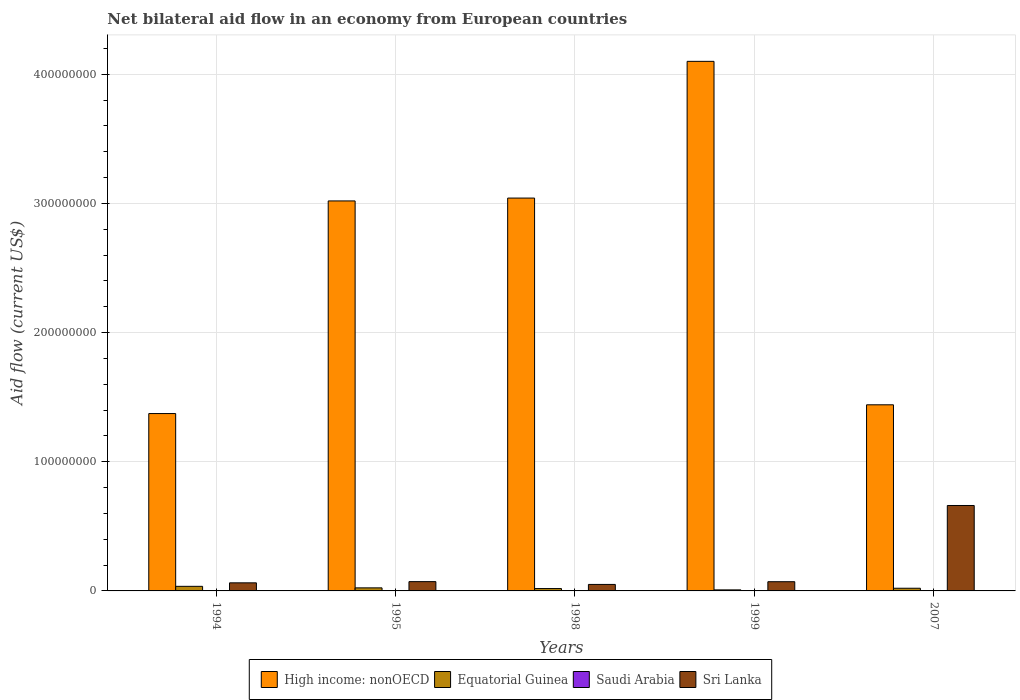How many different coloured bars are there?
Provide a short and direct response. 4. Are the number of bars per tick equal to the number of legend labels?
Give a very brief answer. Yes. How many bars are there on the 5th tick from the left?
Your answer should be very brief. 4. What is the net bilateral aid flow in High income: nonOECD in 1994?
Give a very brief answer. 1.37e+08. Across all years, what is the maximum net bilateral aid flow in High income: nonOECD?
Your response must be concise. 4.10e+08. What is the total net bilateral aid flow in High income: nonOECD in the graph?
Your answer should be very brief. 1.30e+09. What is the difference between the net bilateral aid flow in High income: nonOECD in 1994 and that in 1998?
Provide a succinct answer. -1.67e+08. What is the difference between the net bilateral aid flow in Equatorial Guinea in 1994 and the net bilateral aid flow in Sri Lanka in 1995?
Provide a succinct answer. -3.64e+06. What is the average net bilateral aid flow in Sri Lanka per year?
Keep it short and to the point. 1.83e+07. In the year 1998, what is the difference between the net bilateral aid flow in Sri Lanka and net bilateral aid flow in Equatorial Guinea?
Ensure brevity in your answer.  3.19e+06. In how many years, is the net bilateral aid flow in Equatorial Guinea greater than 80000000 US$?
Offer a terse response. 0. What is the ratio of the net bilateral aid flow in Sri Lanka in 1994 to that in 2007?
Keep it short and to the point. 0.09. Is the net bilateral aid flow in Sri Lanka in 1998 less than that in 2007?
Make the answer very short. Yes. Is the difference between the net bilateral aid flow in Sri Lanka in 1995 and 1998 greater than the difference between the net bilateral aid flow in Equatorial Guinea in 1995 and 1998?
Your response must be concise. Yes. What is the difference between the highest and the second highest net bilateral aid flow in Equatorial Guinea?
Provide a short and direct response. 1.18e+06. What is the difference between the highest and the lowest net bilateral aid flow in Saudi Arabia?
Offer a very short reply. 1.50e+05. In how many years, is the net bilateral aid flow in High income: nonOECD greater than the average net bilateral aid flow in High income: nonOECD taken over all years?
Your answer should be compact. 3. Is it the case that in every year, the sum of the net bilateral aid flow in Equatorial Guinea and net bilateral aid flow in High income: nonOECD is greater than the sum of net bilateral aid flow in Saudi Arabia and net bilateral aid flow in Sri Lanka?
Provide a short and direct response. Yes. What does the 2nd bar from the left in 1998 represents?
Offer a very short reply. Equatorial Guinea. What does the 1st bar from the right in 1998 represents?
Offer a terse response. Sri Lanka. How many bars are there?
Make the answer very short. 20. What is the difference between two consecutive major ticks on the Y-axis?
Provide a short and direct response. 1.00e+08. Are the values on the major ticks of Y-axis written in scientific E-notation?
Provide a succinct answer. No. Does the graph contain grids?
Give a very brief answer. Yes. How are the legend labels stacked?
Provide a succinct answer. Horizontal. What is the title of the graph?
Offer a very short reply. Net bilateral aid flow in an economy from European countries. Does "Myanmar" appear as one of the legend labels in the graph?
Your answer should be compact. No. What is the Aid flow (current US$) of High income: nonOECD in 1994?
Your answer should be very brief. 1.37e+08. What is the Aid flow (current US$) in Equatorial Guinea in 1994?
Offer a very short reply. 3.55e+06. What is the Aid flow (current US$) of Saudi Arabia in 1994?
Keep it short and to the point. 1.10e+05. What is the Aid flow (current US$) in Sri Lanka in 1994?
Keep it short and to the point. 6.26e+06. What is the Aid flow (current US$) of High income: nonOECD in 1995?
Provide a succinct answer. 3.02e+08. What is the Aid flow (current US$) in Equatorial Guinea in 1995?
Your answer should be compact. 2.37e+06. What is the Aid flow (current US$) in Sri Lanka in 1995?
Ensure brevity in your answer.  7.19e+06. What is the Aid flow (current US$) of High income: nonOECD in 1998?
Make the answer very short. 3.04e+08. What is the Aid flow (current US$) in Equatorial Guinea in 1998?
Your answer should be compact. 1.83e+06. What is the Aid flow (current US$) of Saudi Arabia in 1998?
Provide a succinct answer. 10000. What is the Aid flow (current US$) in Sri Lanka in 1998?
Provide a short and direct response. 5.02e+06. What is the Aid flow (current US$) in High income: nonOECD in 1999?
Offer a terse response. 4.10e+08. What is the Aid flow (current US$) of Equatorial Guinea in 1999?
Offer a very short reply. 8.00e+05. What is the Aid flow (current US$) of Sri Lanka in 1999?
Your answer should be very brief. 7.13e+06. What is the Aid flow (current US$) of High income: nonOECD in 2007?
Provide a short and direct response. 1.44e+08. What is the Aid flow (current US$) of Equatorial Guinea in 2007?
Your answer should be very brief. 2.07e+06. What is the Aid flow (current US$) of Saudi Arabia in 2007?
Provide a succinct answer. 10000. What is the Aid flow (current US$) in Sri Lanka in 2007?
Provide a succinct answer. 6.61e+07. Across all years, what is the maximum Aid flow (current US$) of High income: nonOECD?
Your response must be concise. 4.10e+08. Across all years, what is the maximum Aid flow (current US$) of Equatorial Guinea?
Your answer should be compact. 3.55e+06. Across all years, what is the maximum Aid flow (current US$) of Sri Lanka?
Offer a very short reply. 6.61e+07. Across all years, what is the minimum Aid flow (current US$) of High income: nonOECD?
Ensure brevity in your answer.  1.37e+08. Across all years, what is the minimum Aid flow (current US$) in Equatorial Guinea?
Your answer should be very brief. 8.00e+05. Across all years, what is the minimum Aid flow (current US$) in Saudi Arabia?
Make the answer very short. 10000. Across all years, what is the minimum Aid flow (current US$) in Sri Lanka?
Make the answer very short. 5.02e+06. What is the total Aid flow (current US$) in High income: nonOECD in the graph?
Provide a succinct answer. 1.30e+09. What is the total Aid flow (current US$) in Equatorial Guinea in the graph?
Keep it short and to the point. 1.06e+07. What is the total Aid flow (current US$) in Saudi Arabia in the graph?
Your answer should be very brief. 3.70e+05. What is the total Aid flow (current US$) of Sri Lanka in the graph?
Your answer should be compact. 9.17e+07. What is the difference between the Aid flow (current US$) of High income: nonOECD in 1994 and that in 1995?
Offer a terse response. -1.65e+08. What is the difference between the Aid flow (current US$) in Equatorial Guinea in 1994 and that in 1995?
Offer a very short reply. 1.18e+06. What is the difference between the Aid flow (current US$) of Sri Lanka in 1994 and that in 1995?
Your answer should be very brief. -9.30e+05. What is the difference between the Aid flow (current US$) in High income: nonOECD in 1994 and that in 1998?
Ensure brevity in your answer.  -1.67e+08. What is the difference between the Aid flow (current US$) in Equatorial Guinea in 1994 and that in 1998?
Offer a very short reply. 1.72e+06. What is the difference between the Aid flow (current US$) of Sri Lanka in 1994 and that in 1998?
Offer a terse response. 1.24e+06. What is the difference between the Aid flow (current US$) in High income: nonOECD in 1994 and that in 1999?
Your answer should be compact. -2.73e+08. What is the difference between the Aid flow (current US$) in Equatorial Guinea in 1994 and that in 1999?
Ensure brevity in your answer.  2.75e+06. What is the difference between the Aid flow (current US$) in Saudi Arabia in 1994 and that in 1999?
Offer a terse response. 3.00e+04. What is the difference between the Aid flow (current US$) of Sri Lanka in 1994 and that in 1999?
Give a very brief answer. -8.70e+05. What is the difference between the Aid flow (current US$) in High income: nonOECD in 1994 and that in 2007?
Ensure brevity in your answer.  -6.77e+06. What is the difference between the Aid flow (current US$) of Equatorial Guinea in 1994 and that in 2007?
Keep it short and to the point. 1.48e+06. What is the difference between the Aid flow (current US$) in Saudi Arabia in 1994 and that in 2007?
Provide a short and direct response. 1.00e+05. What is the difference between the Aid flow (current US$) in Sri Lanka in 1994 and that in 2007?
Offer a terse response. -5.99e+07. What is the difference between the Aid flow (current US$) in High income: nonOECD in 1995 and that in 1998?
Provide a succinct answer. -2.21e+06. What is the difference between the Aid flow (current US$) of Equatorial Guinea in 1995 and that in 1998?
Your answer should be compact. 5.40e+05. What is the difference between the Aid flow (current US$) in Saudi Arabia in 1995 and that in 1998?
Your answer should be compact. 1.50e+05. What is the difference between the Aid flow (current US$) in Sri Lanka in 1995 and that in 1998?
Provide a succinct answer. 2.17e+06. What is the difference between the Aid flow (current US$) of High income: nonOECD in 1995 and that in 1999?
Your answer should be compact. -1.08e+08. What is the difference between the Aid flow (current US$) of Equatorial Guinea in 1995 and that in 1999?
Give a very brief answer. 1.57e+06. What is the difference between the Aid flow (current US$) in Sri Lanka in 1995 and that in 1999?
Offer a terse response. 6.00e+04. What is the difference between the Aid flow (current US$) in High income: nonOECD in 1995 and that in 2007?
Give a very brief answer. 1.58e+08. What is the difference between the Aid flow (current US$) in Equatorial Guinea in 1995 and that in 2007?
Provide a short and direct response. 3.00e+05. What is the difference between the Aid flow (current US$) of Sri Lanka in 1995 and that in 2007?
Your answer should be compact. -5.90e+07. What is the difference between the Aid flow (current US$) in High income: nonOECD in 1998 and that in 1999?
Keep it short and to the point. -1.06e+08. What is the difference between the Aid flow (current US$) in Equatorial Guinea in 1998 and that in 1999?
Offer a very short reply. 1.03e+06. What is the difference between the Aid flow (current US$) of Sri Lanka in 1998 and that in 1999?
Your response must be concise. -2.11e+06. What is the difference between the Aid flow (current US$) in High income: nonOECD in 1998 and that in 2007?
Provide a short and direct response. 1.60e+08. What is the difference between the Aid flow (current US$) in Equatorial Guinea in 1998 and that in 2007?
Your answer should be compact. -2.40e+05. What is the difference between the Aid flow (current US$) in Sri Lanka in 1998 and that in 2007?
Your answer should be very brief. -6.11e+07. What is the difference between the Aid flow (current US$) of High income: nonOECD in 1999 and that in 2007?
Offer a terse response. 2.66e+08. What is the difference between the Aid flow (current US$) in Equatorial Guinea in 1999 and that in 2007?
Make the answer very short. -1.27e+06. What is the difference between the Aid flow (current US$) in Sri Lanka in 1999 and that in 2007?
Your answer should be compact. -5.90e+07. What is the difference between the Aid flow (current US$) in High income: nonOECD in 1994 and the Aid flow (current US$) in Equatorial Guinea in 1995?
Your answer should be very brief. 1.35e+08. What is the difference between the Aid flow (current US$) in High income: nonOECD in 1994 and the Aid flow (current US$) in Saudi Arabia in 1995?
Make the answer very short. 1.37e+08. What is the difference between the Aid flow (current US$) in High income: nonOECD in 1994 and the Aid flow (current US$) in Sri Lanka in 1995?
Provide a short and direct response. 1.30e+08. What is the difference between the Aid flow (current US$) in Equatorial Guinea in 1994 and the Aid flow (current US$) in Saudi Arabia in 1995?
Provide a succinct answer. 3.39e+06. What is the difference between the Aid flow (current US$) of Equatorial Guinea in 1994 and the Aid flow (current US$) of Sri Lanka in 1995?
Make the answer very short. -3.64e+06. What is the difference between the Aid flow (current US$) of Saudi Arabia in 1994 and the Aid flow (current US$) of Sri Lanka in 1995?
Ensure brevity in your answer.  -7.08e+06. What is the difference between the Aid flow (current US$) of High income: nonOECD in 1994 and the Aid flow (current US$) of Equatorial Guinea in 1998?
Ensure brevity in your answer.  1.35e+08. What is the difference between the Aid flow (current US$) of High income: nonOECD in 1994 and the Aid flow (current US$) of Saudi Arabia in 1998?
Your answer should be very brief. 1.37e+08. What is the difference between the Aid flow (current US$) of High income: nonOECD in 1994 and the Aid flow (current US$) of Sri Lanka in 1998?
Give a very brief answer. 1.32e+08. What is the difference between the Aid flow (current US$) in Equatorial Guinea in 1994 and the Aid flow (current US$) in Saudi Arabia in 1998?
Ensure brevity in your answer.  3.54e+06. What is the difference between the Aid flow (current US$) of Equatorial Guinea in 1994 and the Aid flow (current US$) of Sri Lanka in 1998?
Make the answer very short. -1.47e+06. What is the difference between the Aid flow (current US$) of Saudi Arabia in 1994 and the Aid flow (current US$) of Sri Lanka in 1998?
Make the answer very short. -4.91e+06. What is the difference between the Aid flow (current US$) of High income: nonOECD in 1994 and the Aid flow (current US$) of Equatorial Guinea in 1999?
Give a very brief answer. 1.37e+08. What is the difference between the Aid flow (current US$) in High income: nonOECD in 1994 and the Aid flow (current US$) in Saudi Arabia in 1999?
Make the answer very short. 1.37e+08. What is the difference between the Aid flow (current US$) in High income: nonOECD in 1994 and the Aid flow (current US$) in Sri Lanka in 1999?
Give a very brief answer. 1.30e+08. What is the difference between the Aid flow (current US$) of Equatorial Guinea in 1994 and the Aid flow (current US$) of Saudi Arabia in 1999?
Ensure brevity in your answer.  3.47e+06. What is the difference between the Aid flow (current US$) of Equatorial Guinea in 1994 and the Aid flow (current US$) of Sri Lanka in 1999?
Keep it short and to the point. -3.58e+06. What is the difference between the Aid flow (current US$) of Saudi Arabia in 1994 and the Aid flow (current US$) of Sri Lanka in 1999?
Provide a succinct answer. -7.02e+06. What is the difference between the Aid flow (current US$) in High income: nonOECD in 1994 and the Aid flow (current US$) in Equatorial Guinea in 2007?
Offer a very short reply. 1.35e+08. What is the difference between the Aid flow (current US$) in High income: nonOECD in 1994 and the Aid flow (current US$) in Saudi Arabia in 2007?
Keep it short and to the point. 1.37e+08. What is the difference between the Aid flow (current US$) of High income: nonOECD in 1994 and the Aid flow (current US$) of Sri Lanka in 2007?
Provide a succinct answer. 7.12e+07. What is the difference between the Aid flow (current US$) of Equatorial Guinea in 1994 and the Aid flow (current US$) of Saudi Arabia in 2007?
Ensure brevity in your answer.  3.54e+06. What is the difference between the Aid flow (current US$) of Equatorial Guinea in 1994 and the Aid flow (current US$) of Sri Lanka in 2007?
Ensure brevity in your answer.  -6.26e+07. What is the difference between the Aid flow (current US$) in Saudi Arabia in 1994 and the Aid flow (current US$) in Sri Lanka in 2007?
Keep it short and to the point. -6.60e+07. What is the difference between the Aid flow (current US$) of High income: nonOECD in 1995 and the Aid flow (current US$) of Equatorial Guinea in 1998?
Provide a succinct answer. 3.00e+08. What is the difference between the Aid flow (current US$) in High income: nonOECD in 1995 and the Aid flow (current US$) in Saudi Arabia in 1998?
Provide a succinct answer. 3.02e+08. What is the difference between the Aid flow (current US$) of High income: nonOECD in 1995 and the Aid flow (current US$) of Sri Lanka in 1998?
Make the answer very short. 2.97e+08. What is the difference between the Aid flow (current US$) in Equatorial Guinea in 1995 and the Aid flow (current US$) in Saudi Arabia in 1998?
Provide a short and direct response. 2.36e+06. What is the difference between the Aid flow (current US$) of Equatorial Guinea in 1995 and the Aid flow (current US$) of Sri Lanka in 1998?
Offer a very short reply. -2.65e+06. What is the difference between the Aid flow (current US$) of Saudi Arabia in 1995 and the Aid flow (current US$) of Sri Lanka in 1998?
Offer a very short reply. -4.86e+06. What is the difference between the Aid flow (current US$) in High income: nonOECD in 1995 and the Aid flow (current US$) in Equatorial Guinea in 1999?
Provide a succinct answer. 3.01e+08. What is the difference between the Aid flow (current US$) in High income: nonOECD in 1995 and the Aid flow (current US$) in Saudi Arabia in 1999?
Your answer should be very brief. 3.02e+08. What is the difference between the Aid flow (current US$) of High income: nonOECD in 1995 and the Aid flow (current US$) of Sri Lanka in 1999?
Your response must be concise. 2.95e+08. What is the difference between the Aid flow (current US$) of Equatorial Guinea in 1995 and the Aid flow (current US$) of Saudi Arabia in 1999?
Keep it short and to the point. 2.29e+06. What is the difference between the Aid flow (current US$) of Equatorial Guinea in 1995 and the Aid flow (current US$) of Sri Lanka in 1999?
Your response must be concise. -4.76e+06. What is the difference between the Aid flow (current US$) in Saudi Arabia in 1995 and the Aid flow (current US$) in Sri Lanka in 1999?
Your answer should be compact. -6.97e+06. What is the difference between the Aid flow (current US$) in High income: nonOECD in 1995 and the Aid flow (current US$) in Equatorial Guinea in 2007?
Give a very brief answer. 3.00e+08. What is the difference between the Aid flow (current US$) of High income: nonOECD in 1995 and the Aid flow (current US$) of Saudi Arabia in 2007?
Ensure brevity in your answer.  3.02e+08. What is the difference between the Aid flow (current US$) in High income: nonOECD in 1995 and the Aid flow (current US$) in Sri Lanka in 2007?
Your response must be concise. 2.36e+08. What is the difference between the Aid flow (current US$) of Equatorial Guinea in 1995 and the Aid flow (current US$) of Saudi Arabia in 2007?
Your response must be concise. 2.36e+06. What is the difference between the Aid flow (current US$) in Equatorial Guinea in 1995 and the Aid flow (current US$) in Sri Lanka in 2007?
Your answer should be compact. -6.38e+07. What is the difference between the Aid flow (current US$) in Saudi Arabia in 1995 and the Aid flow (current US$) in Sri Lanka in 2007?
Offer a very short reply. -6.60e+07. What is the difference between the Aid flow (current US$) of High income: nonOECD in 1998 and the Aid flow (current US$) of Equatorial Guinea in 1999?
Your response must be concise. 3.03e+08. What is the difference between the Aid flow (current US$) of High income: nonOECD in 1998 and the Aid flow (current US$) of Saudi Arabia in 1999?
Offer a very short reply. 3.04e+08. What is the difference between the Aid flow (current US$) in High income: nonOECD in 1998 and the Aid flow (current US$) in Sri Lanka in 1999?
Provide a succinct answer. 2.97e+08. What is the difference between the Aid flow (current US$) in Equatorial Guinea in 1998 and the Aid flow (current US$) in Saudi Arabia in 1999?
Make the answer very short. 1.75e+06. What is the difference between the Aid flow (current US$) of Equatorial Guinea in 1998 and the Aid flow (current US$) of Sri Lanka in 1999?
Your response must be concise. -5.30e+06. What is the difference between the Aid flow (current US$) in Saudi Arabia in 1998 and the Aid flow (current US$) in Sri Lanka in 1999?
Your answer should be very brief. -7.12e+06. What is the difference between the Aid flow (current US$) of High income: nonOECD in 1998 and the Aid flow (current US$) of Equatorial Guinea in 2007?
Offer a very short reply. 3.02e+08. What is the difference between the Aid flow (current US$) in High income: nonOECD in 1998 and the Aid flow (current US$) in Saudi Arabia in 2007?
Give a very brief answer. 3.04e+08. What is the difference between the Aid flow (current US$) of High income: nonOECD in 1998 and the Aid flow (current US$) of Sri Lanka in 2007?
Keep it short and to the point. 2.38e+08. What is the difference between the Aid flow (current US$) of Equatorial Guinea in 1998 and the Aid flow (current US$) of Saudi Arabia in 2007?
Provide a short and direct response. 1.82e+06. What is the difference between the Aid flow (current US$) in Equatorial Guinea in 1998 and the Aid flow (current US$) in Sri Lanka in 2007?
Offer a very short reply. -6.43e+07. What is the difference between the Aid flow (current US$) of Saudi Arabia in 1998 and the Aid flow (current US$) of Sri Lanka in 2007?
Make the answer very short. -6.61e+07. What is the difference between the Aid flow (current US$) in High income: nonOECD in 1999 and the Aid flow (current US$) in Equatorial Guinea in 2007?
Your response must be concise. 4.08e+08. What is the difference between the Aid flow (current US$) in High income: nonOECD in 1999 and the Aid flow (current US$) in Saudi Arabia in 2007?
Keep it short and to the point. 4.10e+08. What is the difference between the Aid flow (current US$) of High income: nonOECD in 1999 and the Aid flow (current US$) of Sri Lanka in 2007?
Make the answer very short. 3.44e+08. What is the difference between the Aid flow (current US$) in Equatorial Guinea in 1999 and the Aid flow (current US$) in Saudi Arabia in 2007?
Keep it short and to the point. 7.90e+05. What is the difference between the Aid flow (current US$) of Equatorial Guinea in 1999 and the Aid flow (current US$) of Sri Lanka in 2007?
Your response must be concise. -6.53e+07. What is the difference between the Aid flow (current US$) of Saudi Arabia in 1999 and the Aid flow (current US$) of Sri Lanka in 2007?
Offer a terse response. -6.61e+07. What is the average Aid flow (current US$) of High income: nonOECD per year?
Ensure brevity in your answer.  2.60e+08. What is the average Aid flow (current US$) in Equatorial Guinea per year?
Offer a terse response. 2.12e+06. What is the average Aid flow (current US$) of Saudi Arabia per year?
Provide a short and direct response. 7.40e+04. What is the average Aid flow (current US$) in Sri Lanka per year?
Provide a succinct answer. 1.83e+07. In the year 1994, what is the difference between the Aid flow (current US$) of High income: nonOECD and Aid flow (current US$) of Equatorial Guinea?
Offer a very short reply. 1.34e+08. In the year 1994, what is the difference between the Aid flow (current US$) in High income: nonOECD and Aid flow (current US$) in Saudi Arabia?
Keep it short and to the point. 1.37e+08. In the year 1994, what is the difference between the Aid flow (current US$) of High income: nonOECD and Aid flow (current US$) of Sri Lanka?
Your answer should be compact. 1.31e+08. In the year 1994, what is the difference between the Aid flow (current US$) in Equatorial Guinea and Aid flow (current US$) in Saudi Arabia?
Offer a very short reply. 3.44e+06. In the year 1994, what is the difference between the Aid flow (current US$) in Equatorial Guinea and Aid flow (current US$) in Sri Lanka?
Provide a short and direct response. -2.71e+06. In the year 1994, what is the difference between the Aid flow (current US$) of Saudi Arabia and Aid flow (current US$) of Sri Lanka?
Your response must be concise. -6.15e+06. In the year 1995, what is the difference between the Aid flow (current US$) of High income: nonOECD and Aid flow (current US$) of Equatorial Guinea?
Your response must be concise. 3.00e+08. In the year 1995, what is the difference between the Aid flow (current US$) of High income: nonOECD and Aid flow (current US$) of Saudi Arabia?
Provide a short and direct response. 3.02e+08. In the year 1995, what is the difference between the Aid flow (current US$) of High income: nonOECD and Aid flow (current US$) of Sri Lanka?
Keep it short and to the point. 2.95e+08. In the year 1995, what is the difference between the Aid flow (current US$) in Equatorial Guinea and Aid flow (current US$) in Saudi Arabia?
Provide a succinct answer. 2.21e+06. In the year 1995, what is the difference between the Aid flow (current US$) in Equatorial Guinea and Aid flow (current US$) in Sri Lanka?
Keep it short and to the point. -4.82e+06. In the year 1995, what is the difference between the Aid flow (current US$) in Saudi Arabia and Aid flow (current US$) in Sri Lanka?
Provide a short and direct response. -7.03e+06. In the year 1998, what is the difference between the Aid flow (current US$) of High income: nonOECD and Aid flow (current US$) of Equatorial Guinea?
Give a very brief answer. 3.02e+08. In the year 1998, what is the difference between the Aid flow (current US$) of High income: nonOECD and Aid flow (current US$) of Saudi Arabia?
Ensure brevity in your answer.  3.04e+08. In the year 1998, what is the difference between the Aid flow (current US$) in High income: nonOECD and Aid flow (current US$) in Sri Lanka?
Ensure brevity in your answer.  2.99e+08. In the year 1998, what is the difference between the Aid flow (current US$) in Equatorial Guinea and Aid flow (current US$) in Saudi Arabia?
Ensure brevity in your answer.  1.82e+06. In the year 1998, what is the difference between the Aid flow (current US$) of Equatorial Guinea and Aid flow (current US$) of Sri Lanka?
Your answer should be very brief. -3.19e+06. In the year 1998, what is the difference between the Aid flow (current US$) in Saudi Arabia and Aid flow (current US$) in Sri Lanka?
Offer a very short reply. -5.01e+06. In the year 1999, what is the difference between the Aid flow (current US$) in High income: nonOECD and Aid flow (current US$) in Equatorial Guinea?
Your response must be concise. 4.09e+08. In the year 1999, what is the difference between the Aid flow (current US$) of High income: nonOECD and Aid flow (current US$) of Saudi Arabia?
Your response must be concise. 4.10e+08. In the year 1999, what is the difference between the Aid flow (current US$) of High income: nonOECD and Aid flow (current US$) of Sri Lanka?
Your answer should be compact. 4.03e+08. In the year 1999, what is the difference between the Aid flow (current US$) of Equatorial Guinea and Aid flow (current US$) of Saudi Arabia?
Provide a succinct answer. 7.20e+05. In the year 1999, what is the difference between the Aid flow (current US$) of Equatorial Guinea and Aid flow (current US$) of Sri Lanka?
Give a very brief answer. -6.33e+06. In the year 1999, what is the difference between the Aid flow (current US$) of Saudi Arabia and Aid flow (current US$) of Sri Lanka?
Provide a short and direct response. -7.05e+06. In the year 2007, what is the difference between the Aid flow (current US$) in High income: nonOECD and Aid flow (current US$) in Equatorial Guinea?
Provide a succinct answer. 1.42e+08. In the year 2007, what is the difference between the Aid flow (current US$) in High income: nonOECD and Aid flow (current US$) in Saudi Arabia?
Ensure brevity in your answer.  1.44e+08. In the year 2007, what is the difference between the Aid flow (current US$) of High income: nonOECD and Aid flow (current US$) of Sri Lanka?
Provide a short and direct response. 7.80e+07. In the year 2007, what is the difference between the Aid flow (current US$) of Equatorial Guinea and Aid flow (current US$) of Saudi Arabia?
Your answer should be very brief. 2.06e+06. In the year 2007, what is the difference between the Aid flow (current US$) in Equatorial Guinea and Aid flow (current US$) in Sri Lanka?
Your answer should be compact. -6.41e+07. In the year 2007, what is the difference between the Aid flow (current US$) of Saudi Arabia and Aid flow (current US$) of Sri Lanka?
Your answer should be compact. -6.61e+07. What is the ratio of the Aid flow (current US$) in High income: nonOECD in 1994 to that in 1995?
Ensure brevity in your answer.  0.45. What is the ratio of the Aid flow (current US$) of Equatorial Guinea in 1994 to that in 1995?
Keep it short and to the point. 1.5. What is the ratio of the Aid flow (current US$) of Saudi Arabia in 1994 to that in 1995?
Keep it short and to the point. 0.69. What is the ratio of the Aid flow (current US$) in Sri Lanka in 1994 to that in 1995?
Your answer should be compact. 0.87. What is the ratio of the Aid flow (current US$) of High income: nonOECD in 1994 to that in 1998?
Keep it short and to the point. 0.45. What is the ratio of the Aid flow (current US$) in Equatorial Guinea in 1994 to that in 1998?
Give a very brief answer. 1.94. What is the ratio of the Aid flow (current US$) of Saudi Arabia in 1994 to that in 1998?
Your answer should be very brief. 11. What is the ratio of the Aid flow (current US$) of Sri Lanka in 1994 to that in 1998?
Offer a very short reply. 1.25. What is the ratio of the Aid flow (current US$) of High income: nonOECD in 1994 to that in 1999?
Make the answer very short. 0.33. What is the ratio of the Aid flow (current US$) of Equatorial Guinea in 1994 to that in 1999?
Make the answer very short. 4.44. What is the ratio of the Aid flow (current US$) of Saudi Arabia in 1994 to that in 1999?
Ensure brevity in your answer.  1.38. What is the ratio of the Aid flow (current US$) of Sri Lanka in 1994 to that in 1999?
Ensure brevity in your answer.  0.88. What is the ratio of the Aid flow (current US$) of High income: nonOECD in 1994 to that in 2007?
Provide a short and direct response. 0.95. What is the ratio of the Aid flow (current US$) of Equatorial Guinea in 1994 to that in 2007?
Provide a short and direct response. 1.72. What is the ratio of the Aid flow (current US$) of Saudi Arabia in 1994 to that in 2007?
Provide a short and direct response. 11. What is the ratio of the Aid flow (current US$) in Sri Lanka in 1994 to that in 2007?
Make the answer very short. 0.09. What is the ratio of the Aid flow (current US$) of High income: nonOECD in 1995 to that in 1998?
Keep it short and to the point. 0.99. What is the ratio of the Aid flow (current US$) of Equatorial Guinea in 1995 to that in 1998?
Your response must be concise. 1.3. What is the ratio of the Aid flow (current US$) of Sri Lanka in 1995 to that in 1998?
Provide a short and direct response. 1.43. What is the ratio of the Aid flow (current US$) of High income: nonOECD in 1995 to that in 1999?
Your response must be concise. 0.74. What is the ratio of the Aid flow (current US$) of Equatorial Guinea in 1995 to that in 1999?
Keep it short and to the point. 2.96. What is the ratio of the Aid flow (current US$) of Sri Lanka in 1995 to that in 1999?
Offer a very short reply. 1.01. What is the ratio of the Aid flow (current US$) of High income: nonOECD in 1995 to that in 2007?
Provide a succinct answer. 2.1. What is the ratio of the Aid flow (current US$) in Equatorial Guinea in 1995 to that in 2007?
Your answer should be very brief. 1.14. What is the ratio of the Aid flow (current US$) of Sri Lanka in 1995 to that in 2007?
Your answer should be compact. 0.11. What is the ratio of the Aid flow (current US$) in High income: nonOECD in 1998 to that in 1999?
Give a very brief answer. 0.74. What is the ratio of the Aid flow (current US$) of Equatorial Guinea in 1998 to that in 1999?
Ensure brevity in your answer.  2.29. What is the ratio of the Aid flow (current US$) in Saudi Arabia in 1998 to that in 1999?
Give a very brief answer. 0.12. What is the ratio of the Aid flow (current US$) of Sri Lanka in 1998 to that in 1999?
Offer a terse response. 0.7. What is the ratio of the Aid flow (current US$) of High income: nonOECD in 1998 to that in 2007?
Make the answer very short. 2.11. What is the ratio of the Aid flow (current US$) of Equatorial Guinea in 1998 to that in 2007?
Your answer should be very brief. 0.88. What is the ratio of the Aid flow (current US$) of Saudi Arabia in 1998 to that in 2007?
Provide a succinct answer. 1. What is the ratio of the Aid flow (current US$) of Sri Lanka in 1998 to that in 2007?
Give a very brief answer. 0.08. What is the ratio of the Aid flow (current US$) in High income: nonOECD in 1999 to that in 2007?
Your response must be concise. 2.85. What is the ratio of the Aid flow (current US$) in Equatorial Guinea in 1999 to that in 2007?
Ensure brevity in your answer.  0.39. What is the ratio of the Aid flow (current US$) of Sri Lanka in 1999 to that in 2007?
Your answer should be compact. 0.11. What is the difference between the highest and the second highest Aid flow (current US$) in High income: nonOECD?
Your response must be concise. 1.06e+08. What is the difference between the highest and the second highest Aid flow (current US$) in Equatorial Guinea?
Provide a succinct answer. 1.18e+06. What is the difference between the highest and the second highest Aid flow (current US$) in Saudi Arabia?
Your answer should be very brief. 5.00e+04. What is the difference between the highest and the second highest Aid flow (current US$) in Sri Lanka?
Your answer should be compact. 5.90e+07. What is the difference between the highest and the lowest Aid flow (current US$) in High income: nonOECD?
Keep it short and to the point. 2.73e+08. What is the difference between the highest and the lowest Aid flow (current US$) in Equatorial Guinea?
Keep it short and to the point. 2.75e+06. What is the difference between the highest and the lowest Aid flow (current US$) of Saudi Arabia?
Ensure brevity in your answer.  1.50e+05. What is the difference between the highest and the lowest Aid flow (current US$) in Sri Lanka?
Your answer should be compact. 6.11e+07. 